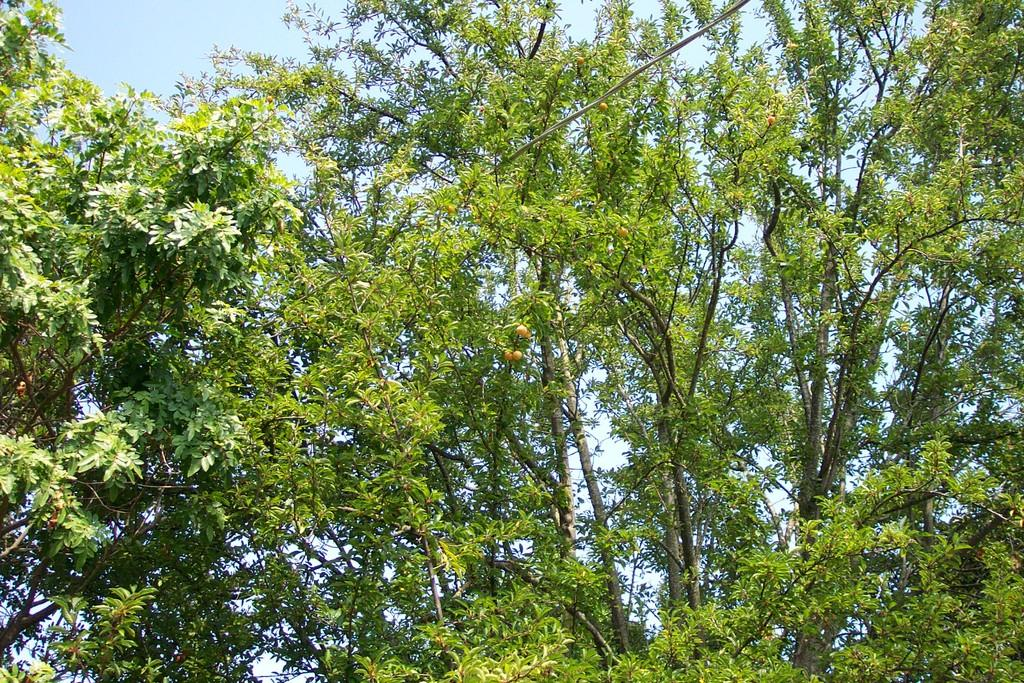What type of vegetation can be seen in the image? There are trees in the image. What else is present in the image besides trees? There are fruits and a wire visible in the image. What can be seen in the sky in the image? The sky is visible in the image. What type of company is located near the harbor in the image? There is no company or harbor present in the image; it only features trees, fruits, and a wire. How many planes can be seen flying over the trees in the image? There are no planes visible in the image. 